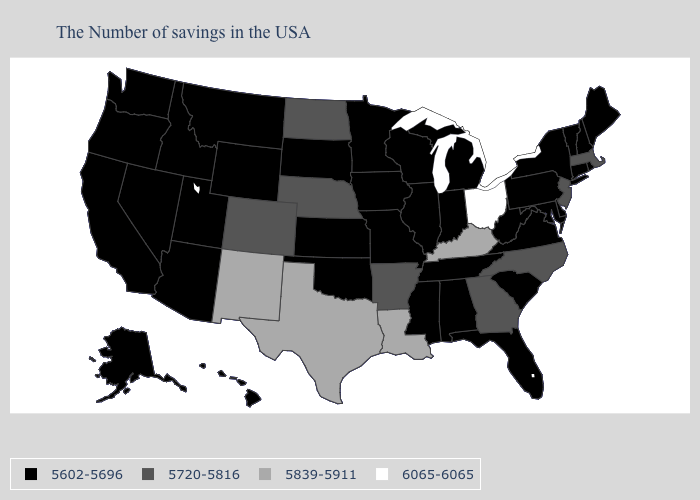What is the value of Indiana?
Keep it brief. 5602-5696. What is the lowest value in states that border Pennsylvania?
Short answer required. 5602-5696. What is the highest value in states that border North Carolina?
Keep it brief. 5720-5816. What is the value of Louisiana?
Write a very short answer. 5839-5911. Name the states that have a value in the range 5839-5911?
Be succinct. Kentucky, Louisiana, Texas, New Mexico. Which states have the lowest value in the USA?
Short answer required. Maine, Rhode Island, New Hampshire, Vermont, Connecticut, New York, Delaware, Maryland, Pennsylvania, Virginia, South Carolina, West Virginia, Florida, Michigan, Indiana, Alabama, Tennessee, Wisconsin, Illinois, Mississippi, Missouri, Minnesota, Iowa, Kansas, Oklahoma, South Dakota, Wyoming, Utah, Montana, Arizona, Idaho, Nevada, California, Washington, Oregon, Alaska, Hawaii. What is the lowest value in states that border Tennessee?
Keep it brief. 5602-5696. Is the legend a continuous bar?
Answer briefly. No. What is the highest value in the USA?
Quick response, please. 6065-6065. Name the states that have a value in the range 6065-6065?
Short answer required. Ohio. Does Virginia have a lower value than Louisiana?
Concise answer only. Yes. What is the value of Nevada?
Give a very brief answer. 5602-5696. What is the value of Virginia?
Answer briefly. 5602-5696. Which states hav the highest value in the West?
Write a very short answer. New Mexico. 